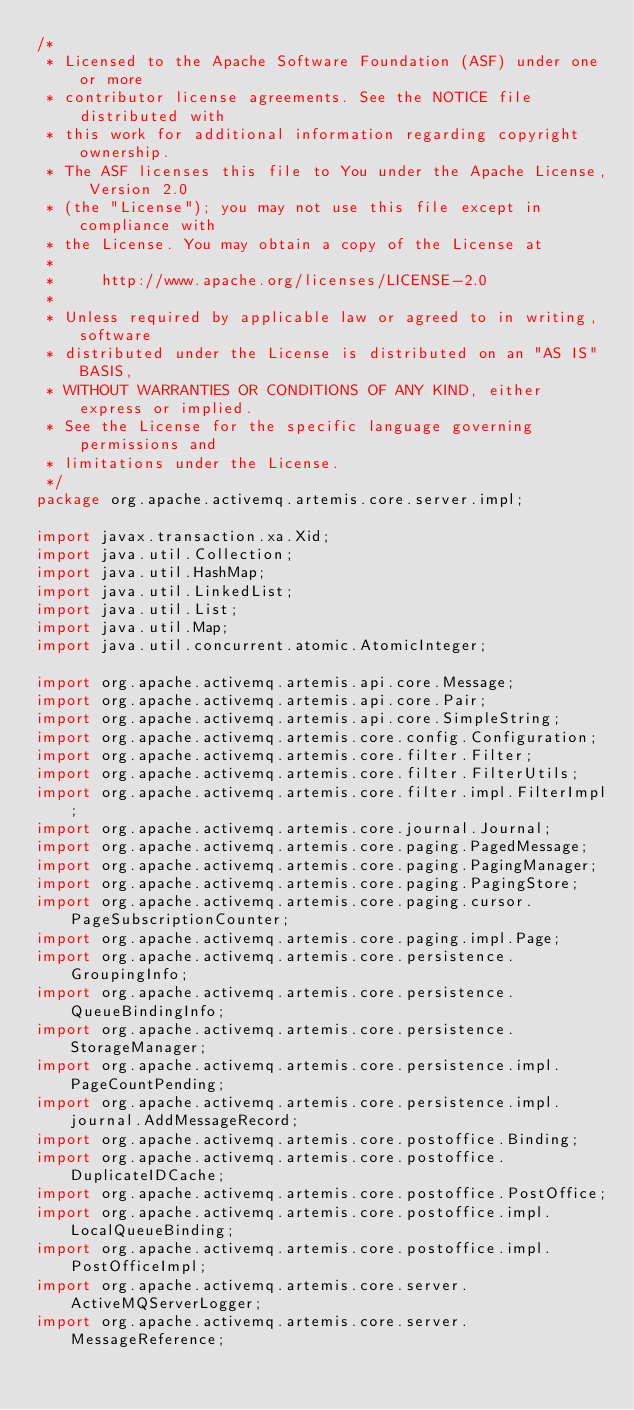<code> <loc_0><loc_0><loc_500><loc_500><_Java_>/*
 * Licensed to the Apache Software Foundation (ASF) under one or more
 * contributor license agreements. See the NOTICE file distributed with
 * this work for additional information regarding copyright ownership.
 * The ASF licenses this file to You under the Apache License, Version 2.0
 * (the "License"); you may not use this file except in compliance with
 * the License. You may obtain a copy of the License at
 *
 *     http://www.apache.org/licenses/LICENSE-2.0
 *
 * Unless required by applicable law or agreed to in writing, software
 * distributed under the License is distributed on an "AS IS" BASIS,
 * WITHOUT WARRANTIES OR CONDITIONS OF ANY KIND, either express or implied.
 * See the License for the specific language governing permissions and
 * limitations under the License.
 */
package org.apache.activemq.artemis.core.server.impl;

import javax.transaction.xa.Xid;
import java.util.Collection;
import java.util.HashMap;
import java.util.LinkedList;
import java.util.List;
import java.util.Map;
import java.util.concurrent.atomic.AtomicInteger;

import org.apache.activemq.artemis.api.core.Message;
import org.apache.activemq.artemis.api.core.Pair;
import org.apache.activemq.artemis.api.core.SimpleString;
import org.apache.activemq.artemis.core.config.Configuration;
import org.apache.activemq.artemis.core.filter.Filter;
import org.apache.activemq.artemis.core.filter.FilterUtils;
import org.apache.activemq.artemis.core.filter.impl.FilterImpl;
import org.apache.activemq.artemis.core.journal.Journal;
import org.apache.activemq.artemis.core.paging.PagedMessage;
import org.apache.activemq.artemis.core.paging.PagingManager;
import org.apache.activemq.artemis.core.paging.PagingStore;
import org.apache.activemq.artemis.core.paging.cursor.PageSubscriptionCounter;
import org.apache.activemq.artemis.core.paging.impl.Page;
import org.apache.activemq.artemis.core.persistence.GroupingInfo;
import org.apache.activemq.artemis.core.persistence.QueueBindingInfo;
import org.apache.activemq.artemis.core.persistence.StorageManager;
import org.apache.activemq.artemis.core.persistence.impl.PageCountPending;
import org.apache.activemq.artemis.core.persistence.impl.journal.AddMessageRecord;
import org.apache.activemq.artemis.core.postoffice.Binding;
import org.apache.activemq.artemis.core.postoffice.DuplicateIDCache;
import org.apache.activemq.artemis.core.postoffice.PostOffice;
import org.apache.activemq.artemis.core.postoffice.impl.LocalQueueBinding;
import org.apache.activemq.artemis.core.postoffice.impl.PostOfficeImpl;
import org.apache.activemq.artemis.core.server.ActiveMQServerLogger;
import org.apache.activemq.artemis.core.server.MessageReference;</code> 